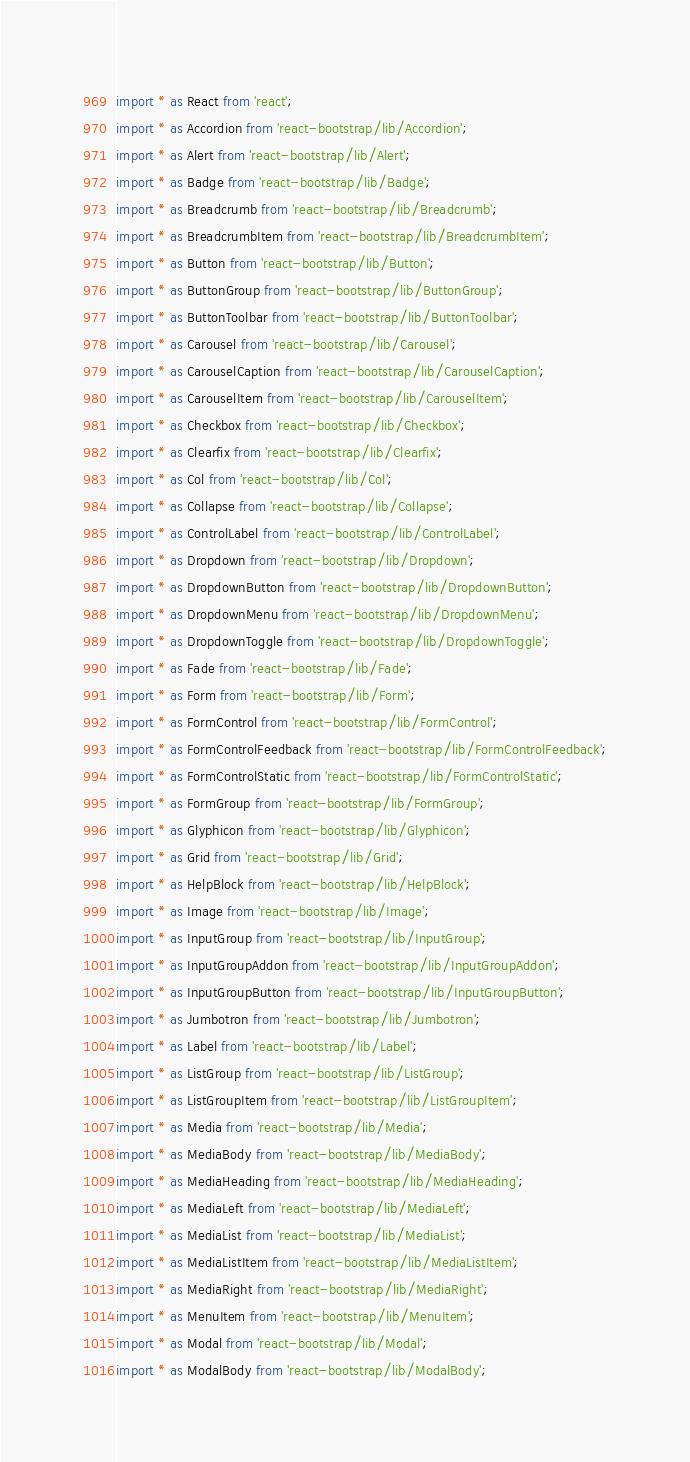Convert code to text. <code><loc_0><loc_0><loc_500><loc_500><_TypeScript_>import * as React from 'react';
import * as Accordion from 'react-bootstrap/lib/Accordion';
import * as Alert from 'react-bootstrap/lib/Alert';
import * as Badge from 'react-bootstrap/lib/Badge';
import * as Breadcrumb from 'react-bootstrap/lib/Breadcrumb';
import * as BreadcrumbItem from 'react-bootstrap/lib/BreadcrumbItem';
import * as Button from 'react-bootstrap/lib/Button';
import * as ButtonGroup from 'react-bootstrap/lib/ButtonGroup';
import * as ButtonToolbar from 'react-bootstrap/lib/ButtonToolbar';
import * as Carousel from 'react-bootstrap/lib/Carousel';
import * as CarouselCaption from 'react-bootstrap/lib/CarouselCaption';
import * as CarouselItem from 'react-bootstrap/lib/CarouselItem';
import * as Checkbox from 'react-bootstrap/lib/Checkbox';
import * as Clearfix from 'react-bootstrap/lib/Clearfix';
import * as Col from 'react-bootstrap/lib/Col';
import * as Collapse from 'react-bootstrap/lib/Collapse';
import * as ControlLabel from 'react-bootstrap/lib/ControlLabel';
import * as Dropdown from 'react-bootstrap/lib/Dropdown';
import * as DropdownButton from 'react-bootstrap/lib/DropdownButton';
import * as DropdownMenu from 'react-bootstrap/lib/DropdownMenu';
import * as DropdownToggle from 'react-bootstrap/lib/DropdownToggle';
import * as Fade from 'react-bootstrap/lib/Fade';
import * as Form from 'react-bootstrap/lib/Form';
import * as FormControl from 'react-bootstrap/lib/FormControl';
import * as FormControlFeedback from 'react-bootstrap/lib/FormControlFeedback';
import * as FormControlStatic from 'react-bootstrap/lib/FormControlStatic';
import * as FormGroup from 'react-bootstrap/lib/FormGroup';
import * as Glyphicon from 'react-bootstrap/lib/Glyphicon';
import * as Grid from 'react-bootstrap/lib/Grid';
import * as HelpBlock from 'react-bootstrap/lib/HelpBlock';
import * as Image from 'react-bootstrap/lib/Image';
import * as InputGroup from 'react-bootstrap/lib/InputGroup';
import * as InputGroupAddon from 'react-bootstrap/lib/InputGroupAddon';
import * as InputGroupButton from 'react-bootstrap/lib/InputGroupButton';
import * as Jumbotron from 'react-bootstrap/lib/Jumbotron';
import * as Label from 'react-bootstrap/lib/Label';
import * as ListGroup from 'react-bootstrap/lib/ListGroup';
import * as ListGroupItem from 'react-bootstrap/lib/ListGroupItem';
import * as Media from 'react-bootstrap/lib/Media';
import * as MediaBody from 'react-bootstrap/lib/MediaBody';
import * as MediaHeading from 'react-bootstrap/lib/MediaHeading';
import * as MediaLeft from 'react-bootstrap/lib/MediaLeft';
import * as MediaList from 'react-bootstrap/lib/MediaList';
import * as MediaListItem from 'react-bootstrap/lib/MediaListItem';
import * as MediaRight from 'react-bootstrap/lib/MediaRight';
import * as MenuItem from 'react-bootstrap/lib/MenuItem';
import * as Modal from 'react-bootstrap/lib/Modal';
import * as ModalBody from 'react-bootstrap/lib/ModalBody';</code> 